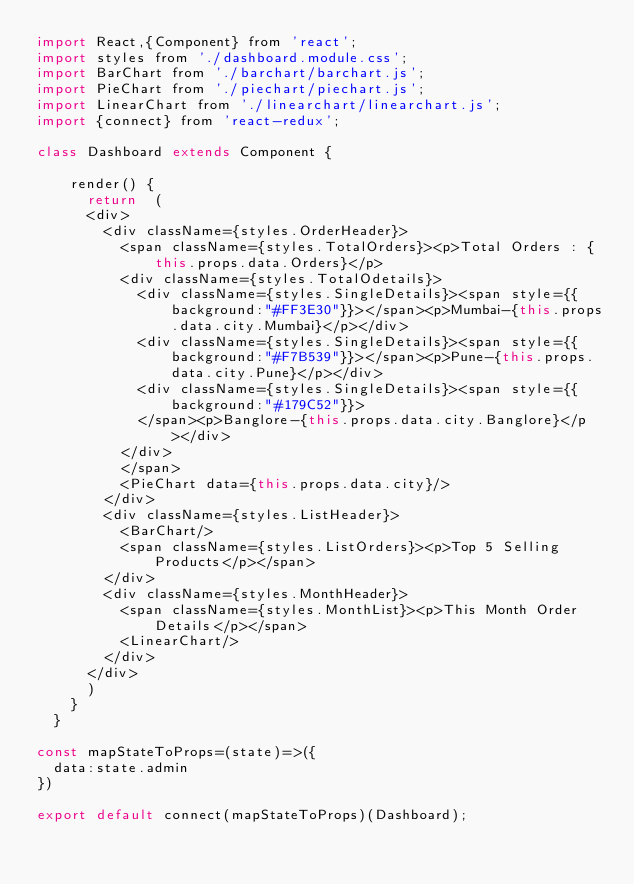<code> <loc_0><loc_0><loc_500><loc_500><_JavaScript_>import React,{Component} from 'react';
import styles from './dashboard.module.css';
import BarChart from './barchart/barchart.js';
import PieChart from './piechart/piechart.js';
import LinearChart from './linearchart/linearchart.js';
import {connect} from 'react-redux';

class Dashboard extends Component {

    render() {
      return  (
      <div>
        <div className={styles.OrderHeader}>
          <span className={styles.TotalOrders}><p>Total Orders : {this.props.data.Orders}</p>
          <div className={styles.TotalOdetails}>
            <div className={styles.SingleDetails}><span style={{background:"#FF3E30"}}></span><p>Mumbai-{this.props.data.city.Mumbai}</p></div>
            <div className={styles.SingleDetails}><span style={{background:"#F7B539"}}></span><p>Pune-{this.props.data.city.Pune}</p></div>
            <div className={styles.SingleDetails}><span style={{background:"#179C52"}}>
            </span><p>Banglore-{this.props.data.city.Banglore}</p></div>
          </div>
          </span>
          <PieChart data={this.props.data.city}/>
        </div>
        <div className={styles.ListHeader}>
          <BarChart/>
          <span className={styles.ListOrders}><p>Top 5 Selling Products</p></span>
        </div>
        <div className={styles.MonthHeader}>
          <span className={styles.MonthList}><p>This Month Order Details</p></span>
          <LinearChart/>
        </div>
      </div>
      )
    }
  }

const mapStateToProps=(state)=>({
  data:state.admin
})

export default connect(mapStateToProps)(Dashboard);
</code> 